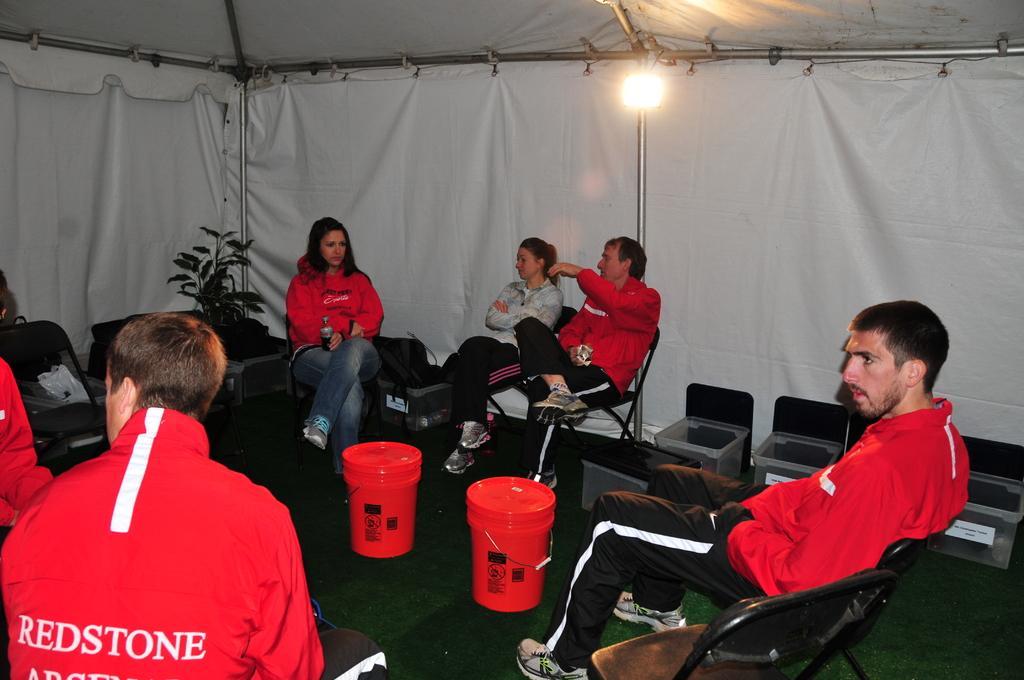Could you give a brief overview of what you see in this image? In this picture there are group of persons sitting. In the Center there are two objects which are red in colour and in the background there is a white colour curtain and there are rods and there is a light, there is a plant on the right side, there are white coloured containers. On the left side there is some text written on the jacket which is red in colour. 